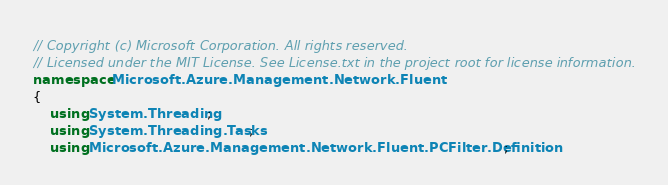<code> <loc_0><loc_0><loc_500><loc_500><_C#_>// Copyright (c) Microsoft Corporation. All rights reserved.
// Licensed under the MIT License. See License.txt in the project root for license information.
namespace Microsoft.Azure.Management.Network.Fluent
{
    using System.Threading;
    using System.Threading.Tasks;
    using Microsoft.Azure.Management.Network.Fluent.PCFilter.Definition;</code> 